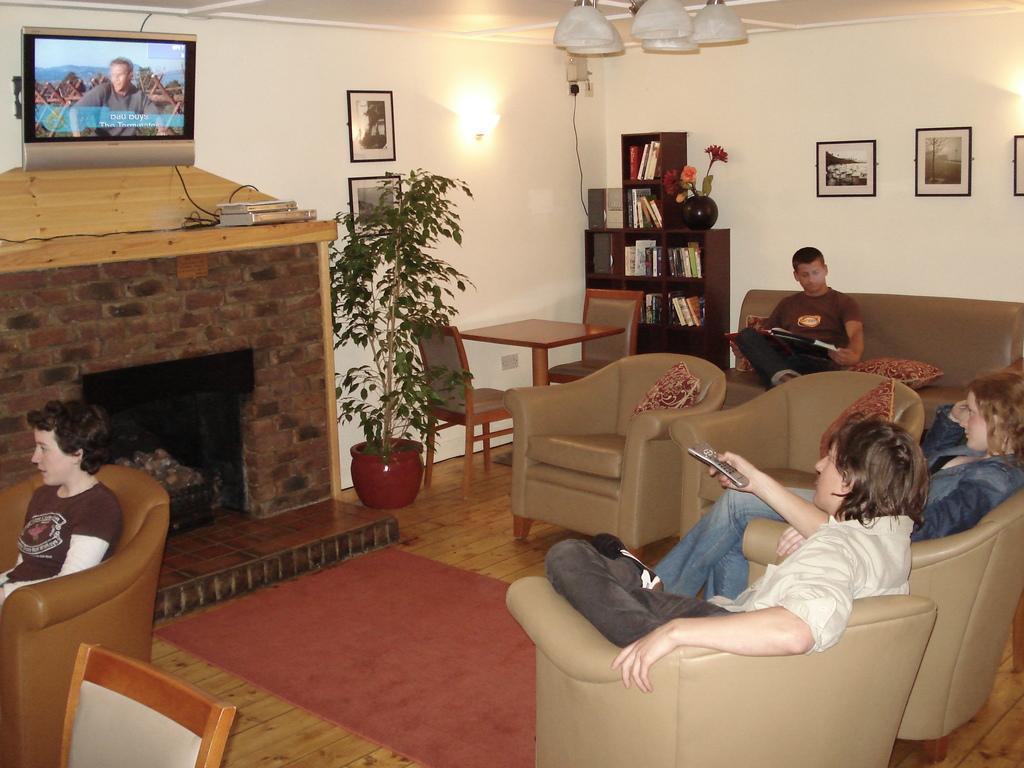Could you give a brief overview of what you see in this image? In this image I see 4 persons who are sitting on the couch and there are chairs and a table over here and I can also see a plant. In the background I see the wall, photo frames on it, rack of full of books and other things and I see a TV over here. 